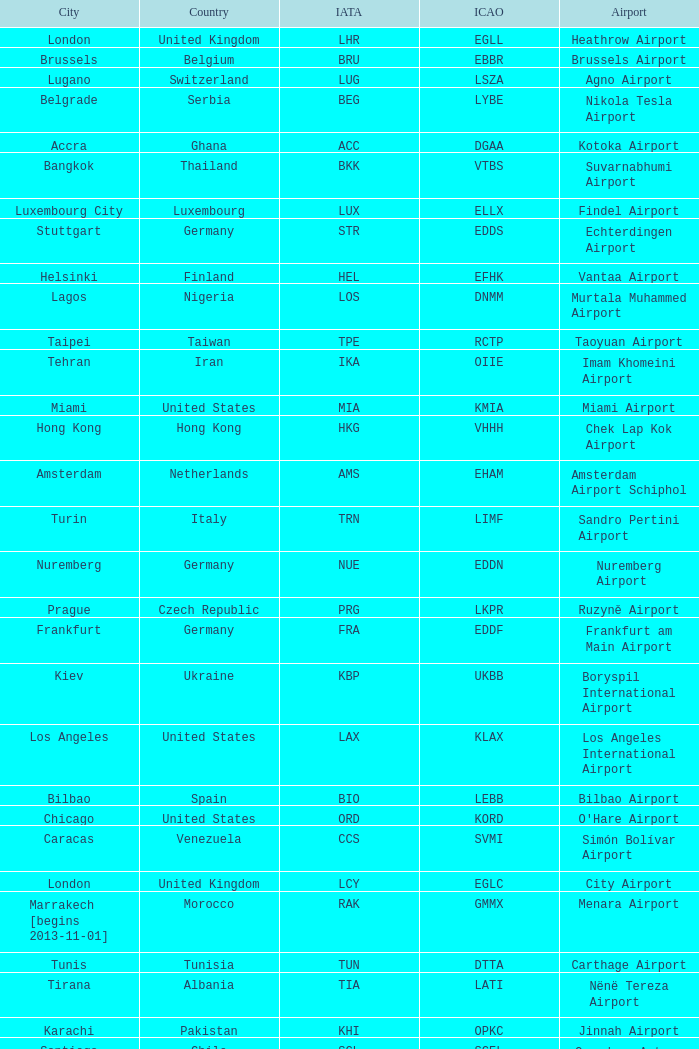What city is fuhlsbüttel airport in? Hamburg. 